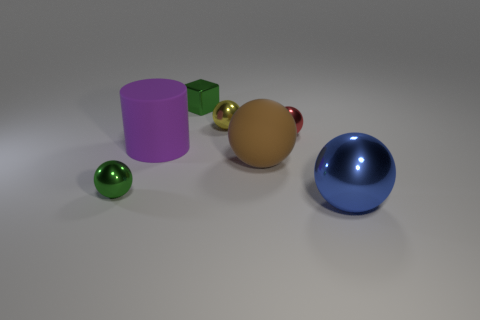There is a green shiny object that is to the left of the green metallic block; what shape is it? The green shiny object located to the left of the green metallic block is a sphere, exhibiting a smooth and reflective surface indicative of its perfectly round shape. 